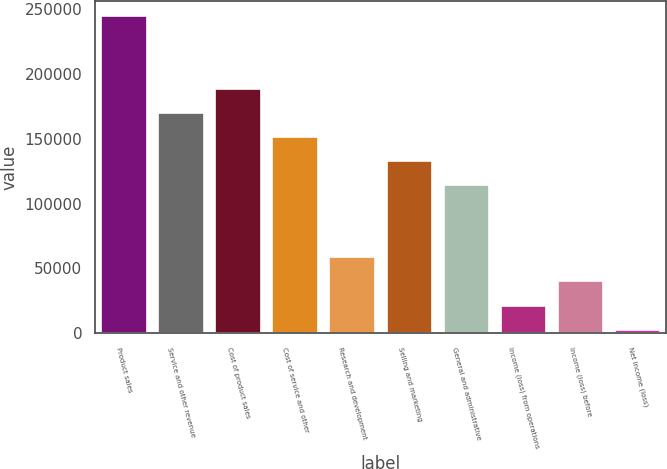Convert chart to OTSL. <chart><loc_0><loc_0><loc_500><loc_500><bar_chart><fcel>Product sales<fcel>Service and other revenue<fcel>Cost of product sales<fcel>Cost of service and other<fcel>Research and development<fcel>Selling and marketing<fcel>General and administrative<fcel>Income (loss) from operations<fcel>Income (loss) before<fcel>Net income (loss)<nl><fcel>244319<fcel>170031<fcel>188603<fcel>151459<fcel>58598.3<fcel>132887<fcel>114315<fcel>21454.1<fcel>40026.2<fcel>2882<nl></chart> 